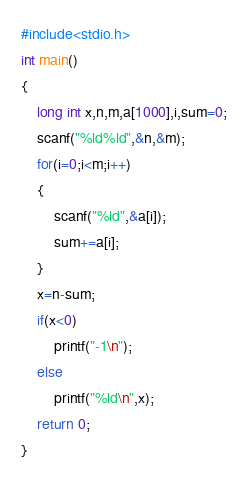<code> <loc_0><loc_0><loc_500><loc_500><_C_>#include<stdio.h>
int main()
{
    long int x,n,m,a[1000],i,sum=0;
    scanf("%ld%ld",&n,&m);
    for(i=0;i<m;i++)
    {
        scanf("%ld",&a[i]);
        sum+=a[i];
    }
    x=n-sum;
    if(x<0)
        printf("-1\n");
    else
        printf("%ld\n",x);
    return 0;
}
</code> 